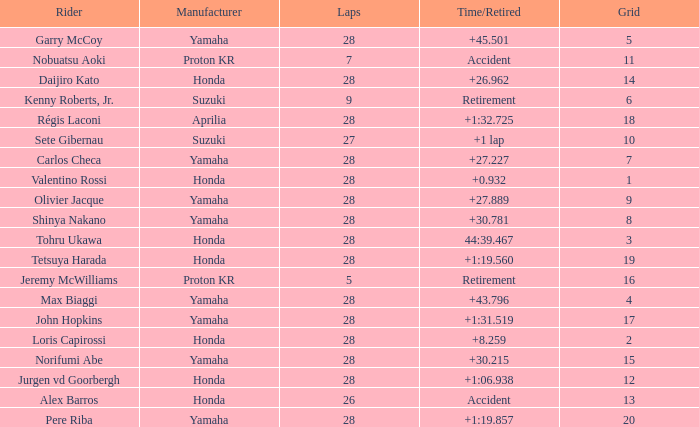How many laps were in grid 4? 28.0. 